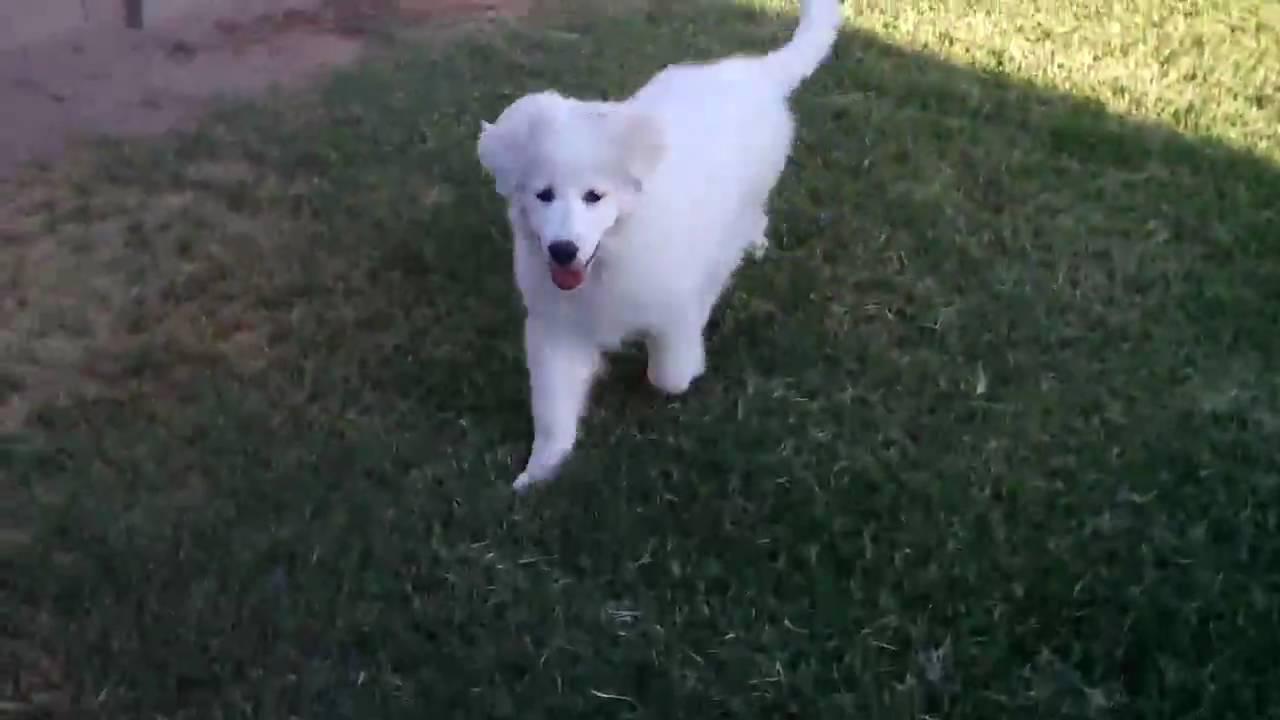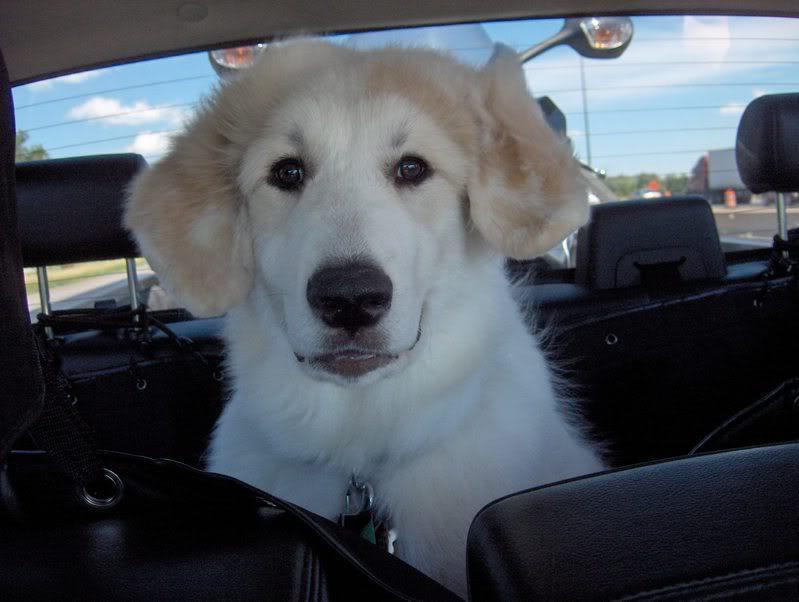The first image is the image on the left, the second image is the image on the right. Given the left and right images, does the statement "One of the images features a single dog laying on grass." hold true? Answer yes or no. No. The first image is the image on the left, the second image is the image on the right. Analyze the images presented: Is the assertion "A white dog is lying on green grass in both images." valid? Answer yes or no. No. 